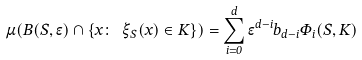<formula> <loc_0><loc_0><loc_500><loc_500>\mu ( B ( S , \epsilon ) \cap \{ x \colon \ \xi _ { S } ( x ) \in K \} ) = \sum _ { i = 0 } ^ { d } { \epsilon ^ { d - i } b _ { d - i } \Phi _ { i } ( S , K ) }</formula> 